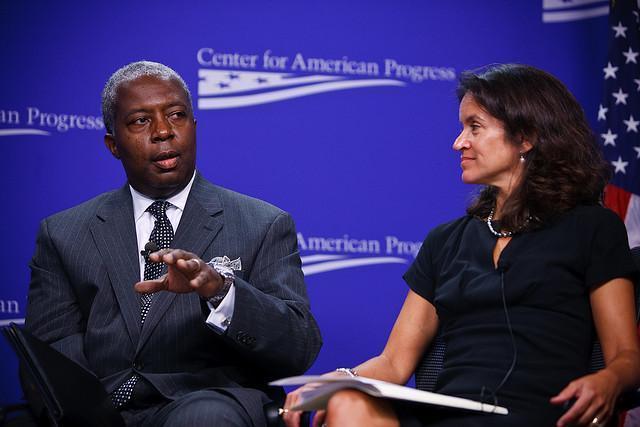How many people can you see?
Give a very brief answer. 2. 